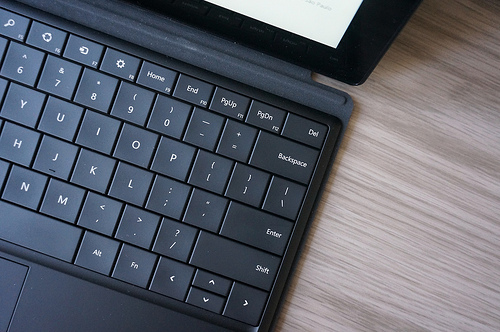<image>
Is the laptop under the table? No. The laptop is not positioned under the table. The vertical relationship between these objects is different. 